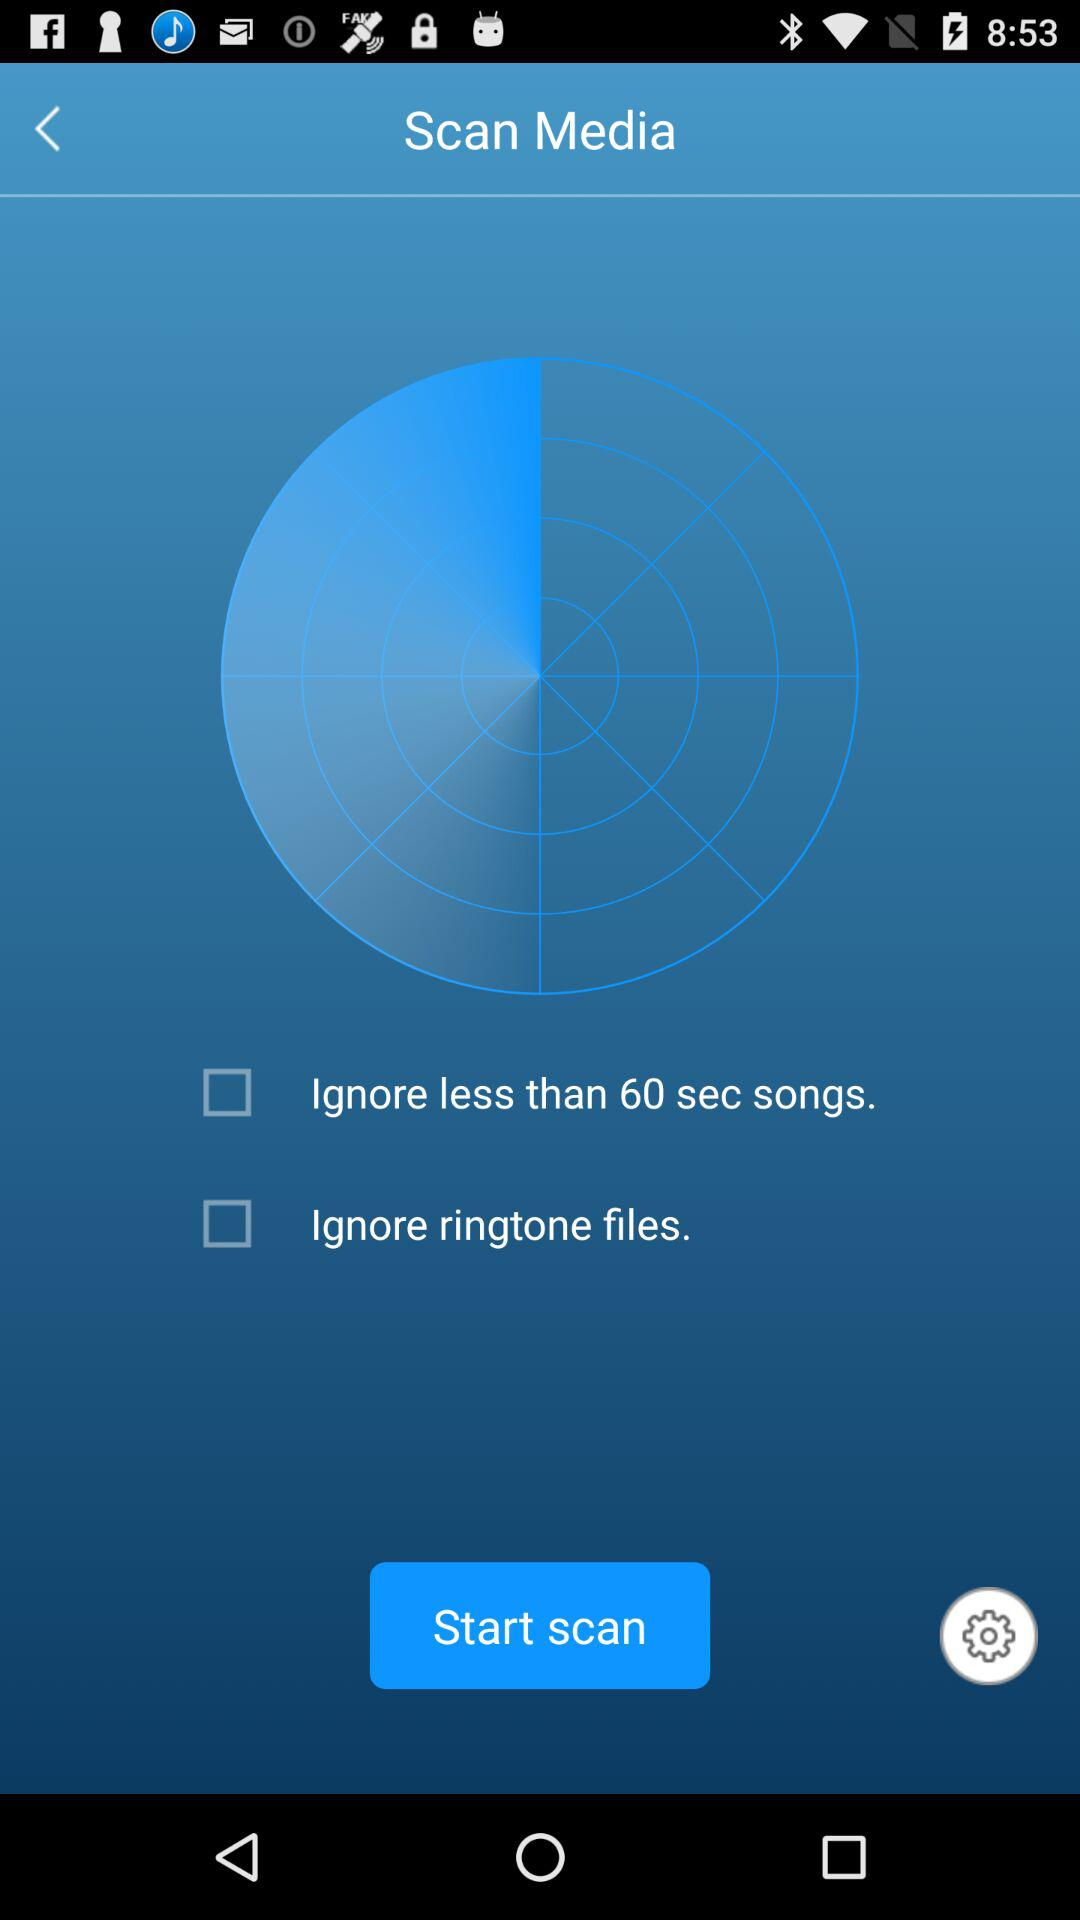What is the status of "Ignore ringtone files"? The status is "off". 